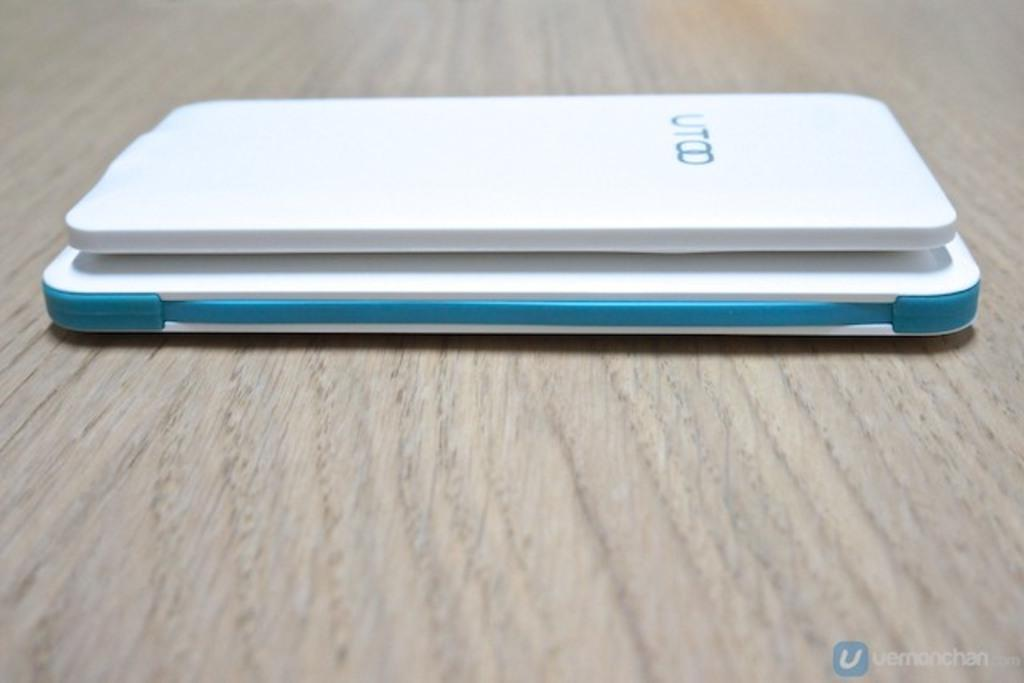<image>
Create a compact narrative representing the image presented. A blue and white UT00 device sits on a table. 